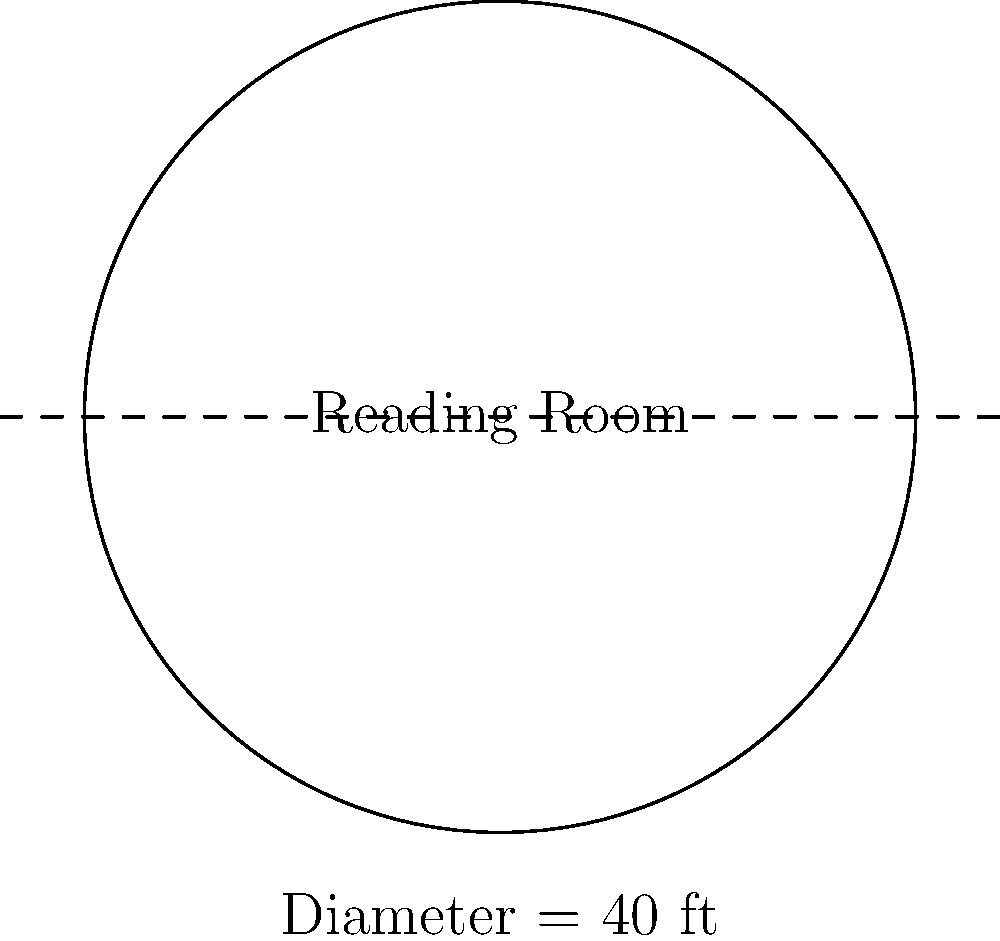The University of Virginia's historic Rotunda building features a circular reading room. If the diameter of this room is 40 feet, what is its circumference? (Use $\pi \approx 3.14$ for your calculations) To solve this problem, we'll follow these steps:

1) Recall the formula for the circumference of a circle:
   $C = \pi d$, where $C$ is the circumference, $\pi$ is pi, and $d$ is the diameter.

2) We're given that the diameter is 40 feet, so we'll substitute this into our formula:
   $C = \pi \times 40$

3) We're told to use $\pi \approx 3.14$, so let's substitute this value:
   $C = 3.14 \times 40$

4) Now we simply multiply:
   $C = 125.6$ feet

5) Rounding to the nearest foot:
   $C \approx 126$ feet

Therefore, the circumference of the circular reading room is approximately 126 feet.
Answer: 126 feet 